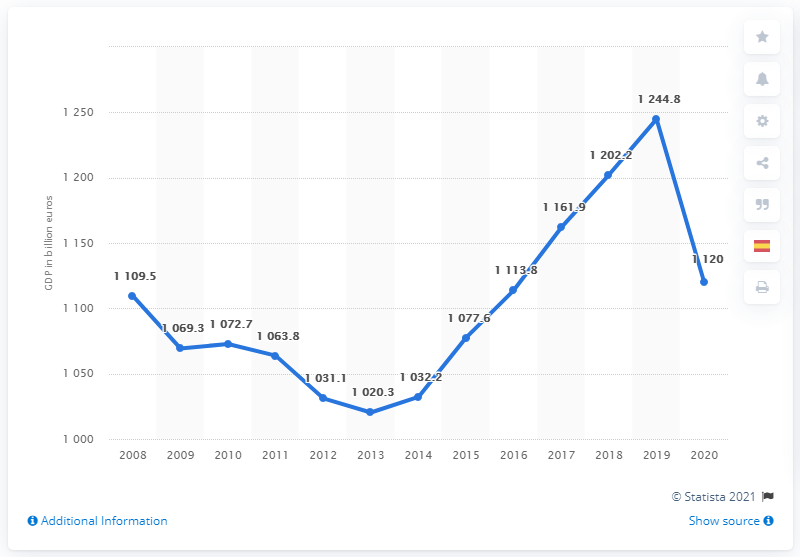Give some essential details in this illustration. In 2020, Spain's GDP was 1,120. The GDP of 2009 was higher than the GDP of 2008 by 40.2%. In 2013, Spain's Gross Domestic Product (GDP) was 1032.2. In 2020, the Gross Domestic Product (GDP) declined significantly. According to projections, Spain's Gross Domestic Product (GDP) was expected to reach 1161.9 in the year 2017. 